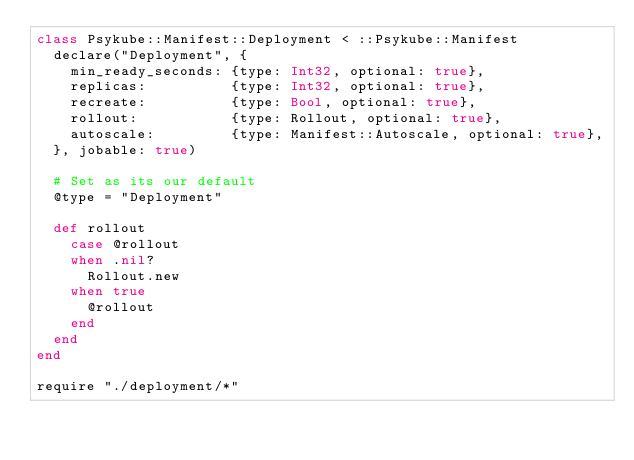Convert code to text. <code><loc_0><loc_0><loc_500><loc_500><_Crystal_>class Psykube::Manifest::Deployment < ::Psykube::Manifest
  declare("Deployment", {
    min_ready_seconds: {type: Int32, optional: true},
    replicas:          {type: Int32, optional: true},
    recreate:          {type: Bool, optional: true},
    rollout:           {type: Rollout, optional: true},
    autoscale:         {type: Manifest::Autoscale, optional: true},
  }, jobable: true)

  # Set as its our default
  @type = "Deployment"

  def rollout
    case @rollout
    when .nil?
      Rollout.new
    when true
      @rollout
    end
  end
end

require "./deployment/*"
</code> 